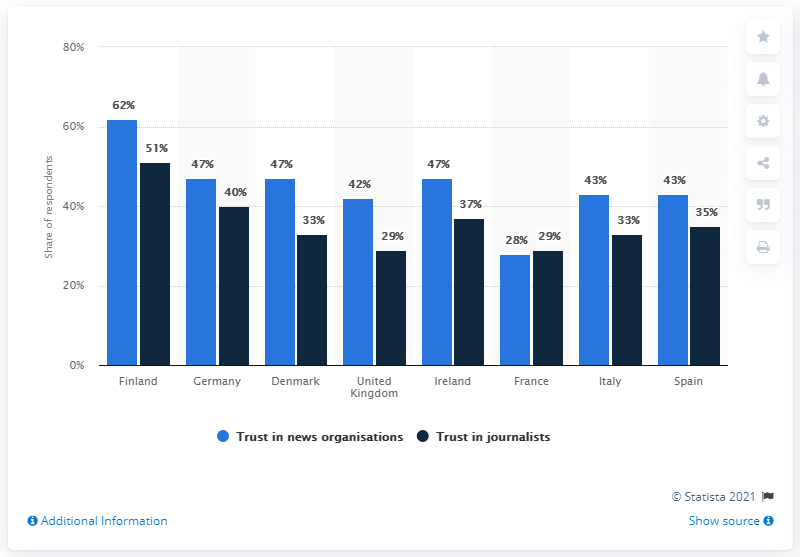Look at Finland data and find how many percentage respondents have Trust in Journalists ? According to the given dataset, 51% of the respondents in Finland have trust in journalists. It's interesting to note that this level of trust is relatively high compared to some other countries presented, reflecting the public's confidence in journalistic integrity and standards within Finland. 